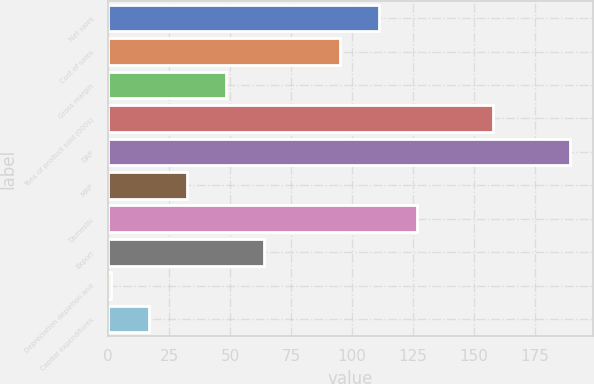Convert chart to OTSL. <chart><loc_0><loc_0><loc_500><loc_500><bar_chart><fcel>Net sales<fcel>Cost of sales<fcel>Gross margin<fcel>Tons of product sold (000s)<fcel>DAP<fcel>MAP<fcel>Domestic<fcel>Export<fcel>Depreciation depletion and<fcel>Capital expenditures<nl><fcel>110.93<fcel>95.24<fcel>48.17<fcel>158<fcel>189.38<fcel>32.48<fcel>126.62<fcel>63.86<fcel>1.1<fcel>16.79<nl></chart> 